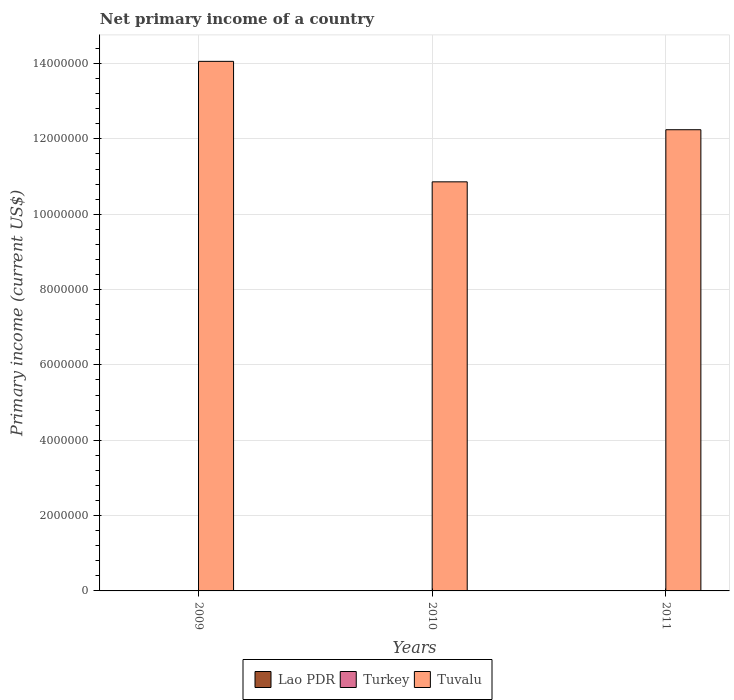How many bars are there on the 1st tick from the left?
Provide a succinct answer. 1. How many bars are there on the 1st tick from the right?
Your response must be concise. 1. What is the label of the 3rd group of bars from the left?
Your response must be concise. 2011. What is the primary income in Tuvalu in 2010?
Ensure brevity in your answer.  1.09e+07. Across all years, what is the maximum primary income in Tuvalu?
Make the answer very short. 1.41e+07. In which year was the primary income in Tuvalu maximum?
Offer a very short reply. 2009. What is the total primary income in Tuvalu in the graph?
Give a very brief answer. 3.72e+07. What is the difference between the primary income in Tuvalu in 2009 and that in 2011?
Offer a terse response. 1.81e+06. What is the difference between the primary income in Lao PDR in 2011 and the primary income in Tuvalu in 2010?
Offer a terse response. -1.09e+07. In how many years, is the primary income in Tuvalu greater than 6000000 US$?
Give a very brief answer. 3. What is the ratio of the primary income in Tuvalu in 2009 to that in 2010?
Offer a terse response. 1.29. Is the primary income in Tuvalu in 2009 less than that in 2010?
Your answer should be compact. No. What is the difference between the highest and the second highest primary income in Tuvalu?
Give a very brief answer. 1.81e+06. What is the difference between the highest and the lowest primary income in Tuvalu?
Keep it short and to the point. 3.20e+06. Is the sum of the primary income in Tuvalu in 2010 and 2011 greater than the maximum primary income in Turkey across all years?
Ensure brevity in your answer.  Yes. How many bars are there?
Make the answer very short. 3. How many years are there in the graph?
Give a very brief answer. 3. Are the values on the major ticks of Y-axis written in scientific E-notation?
Offer a very short reply. No. Does the graph contain grids?
Ensure brevity in your answer.  Yes. How many legend labels are there?
Offer a very short reply. 3. How are the legend labels stacked?
Make the answer very short. Horizontal. What is the title of the graph?
Give a very brief answer. Net primary income of a country. Does "Iran" appear as one of the legend labels in the graph?
Make the answer very short. No. What is the label or title of the X-axis?
Your answer should be compact. Years. What is the label or title of the Y-axis?
Provide a short and direct response. Primary income (current US$). What is the Primary income (current US$) of Turkey in 2009?
Provide a short and direct response. 0. What is the Primary income (current US$) in Tuvalu in 2009?
Your response must be concise. 1.41e+07. What is the Primary income (current US$) in Lao PDR in 2010?
Keep it short and to the point. 0. What is the Primary income (current US$) in Turkey in 2010?
Ensure brevity in your answer.  0. What is the Primary income (current US$) in Tuvalu in 2010?
Your response must be concise. 1.09e+07. What is the Primary income (current US$) in Turkey in 2011?
Provide a succinct answer. 0. What is the Primary income (current US$) of Tuvalu in 2011?
Give a very brief answer. 1.22e+07. Across all years, what is the maximum Primary income (current US$) of Tuvalu?
Provide a short and direct response. 1.41e+07. Across all years, what is the minimum Primary income (current US$) in Tuvalu?
Your answer should be very brief. 1.09e+07. What is the total Primary income (current US$) of Turkey in the graph?
Keep it short and to the point. 0. What is the total Primary income (current US$) in Tuvalu in the graph?
Offer a terse response. 3.72e+07. What is the difference between the Primary income (current US$) of Tuvalu in 2009 and that in 2010?
Keep it short and to the point. 3.20e+06. What is the difference between the Primary income (current US$) of Tuvalu in 2009 and that in 2011?
Ensure brevity in your answer.  1.81e+06. What is the difference between the Primary income (current US$) of Tuvalu in 2010 and that in 2011?
Your answer should be very brief. -1.38e+06. What is the average Primary income (current US$) in Tuvalu per year?
Offer a terse response. 1.24e+07. What is the ratio of the Primary income (current US$) in Tuvalu in 2009 to that in 2010?
Ensure brevity in your answer.  1.29. What is the ratio of the Primary income (current US$) in Tuvalu in 2009 to that in 2011?
Ensure brevity in your answer.  1.15. What is the ratio of the Primary income (current US$) of Tuvalu in 2010 to that in 2011?
Your answer should be compact. 0.89. What is the difference between the highest and the second highest Primary income (current US$) in Tuvalu?
Offer a terse response. 1.81e+06. What is the difference between the highest and the lowest Primary income (current US$) in Tuvalu?
Provide a short and direct response. 3.20e+06. 